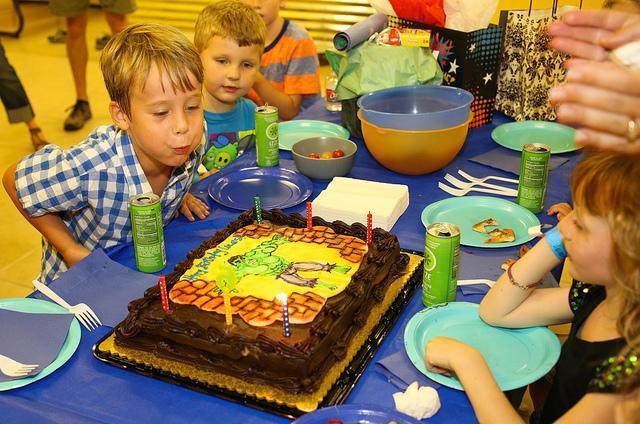How many people are there?
Give a very brief answer. 6. How many bowls are there?
Give a very brief answer. 3. 